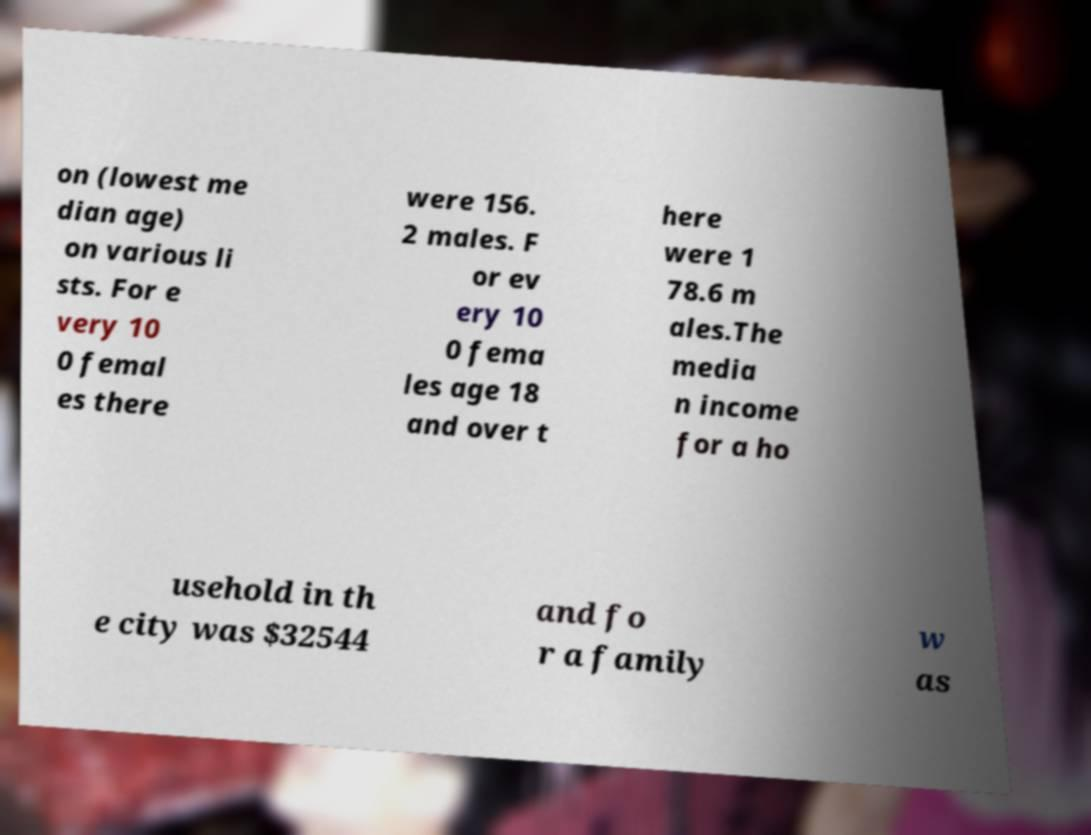What messages or text are displayed in this image? I need them in a readable, typed format. on (lowest me dian age) on various li sts. For e very 10 0 femal es there were 156. 2 males. F or ev ery 10 0 fema les age 18 and over t here were 1 78.6 m ales.The media n income for a ho usehold in th e city was $32544 and fo r a family w as 